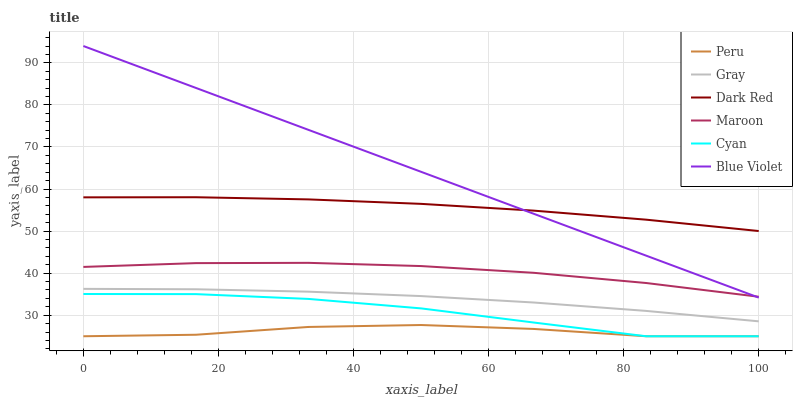Does Dark Red have the minimum area under the curve?
Answer yes or no. No. Does Dark Red have the maximum area under the curve?
Answer yes or no. No. Is Dark Red the smoothest?
Answer yes or no. No. Is Dark Red the roughest?
Answer yes or no. No. Does Maroon have the lowest value?
Answer yes or no. No. Does Dark Red have the highest value?
Answer yes or no. No. Is Cyan less than Dark Red?
Answer yes or no. Yes. Is Dark Red greater than Gray?
Answer yes or no. Yes. Does Cyan intersect Dark Red?
Answer yes or no. No. 